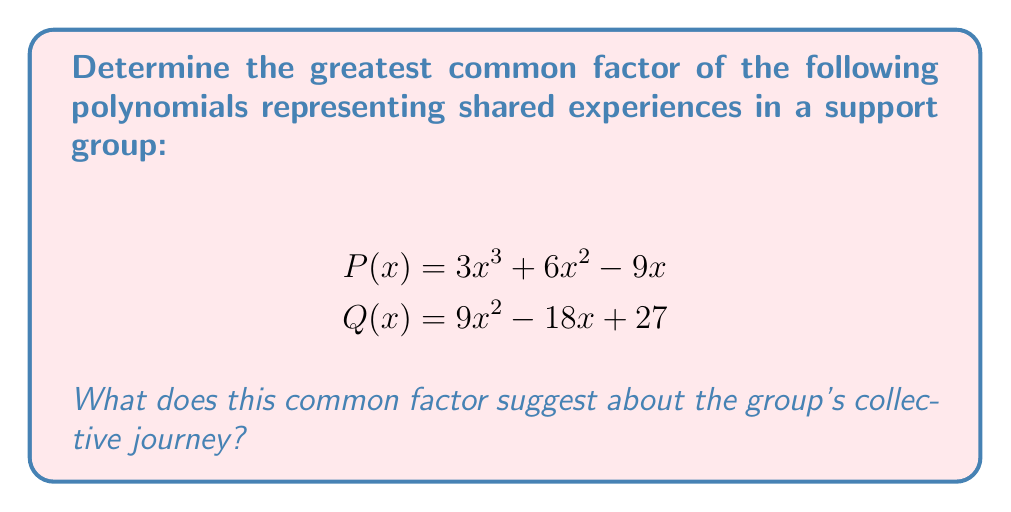Can you answer this question? To find the greatest common factor (GCF) of these polynomials, we'll follow these steps:

1. Factor out the GCF of the coefficients in each polynomial:
   $P(x) = 3(x^3 + 2x^2 - 3x)$
   $Q(x) = 9(x^2 - 2x + 3)$

2. Identify the common factor between the coefficients:
   GCF of 3 and 9 is 3

3. Determine the common variable factor with the lowest exponent:
   $P(x)$ has $x$ with a minimum exponent of 1
   $Q(x)$ has no $x$ factor for all terms

4. Combine the numeric and variable factors:
   The GCF is $3$

5. Interpretation:
   The common factor of 3 suggests a shared foundation or starting point in the group's experiences. It represents the common thread that connects their individual journeys, symbolizing the strength found in shared understanding and mutual support.
Answer: $3$ 